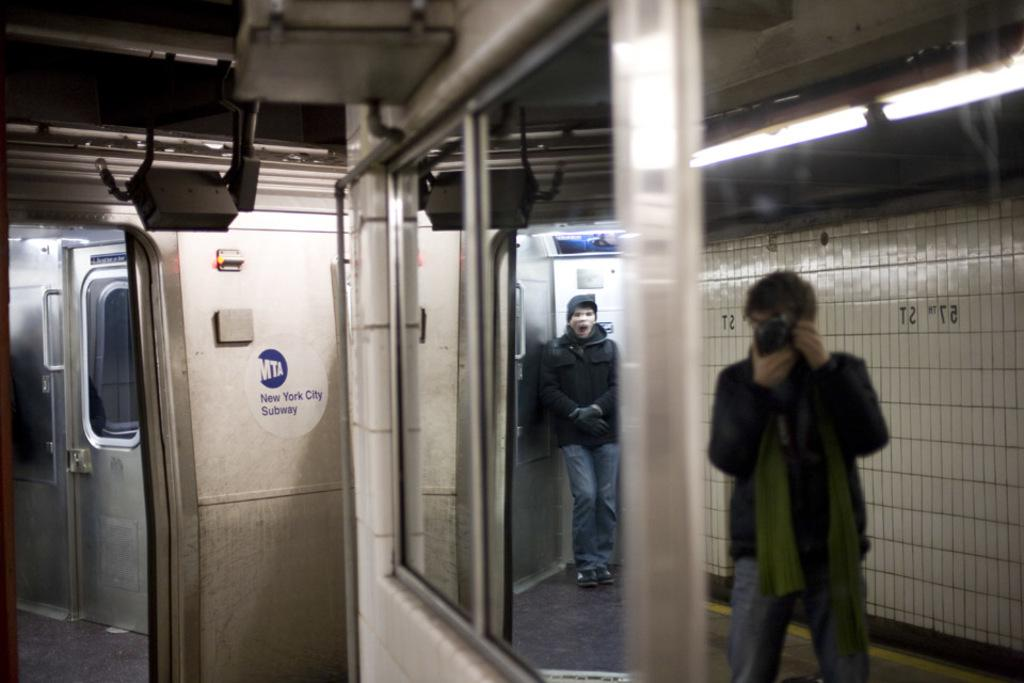<image>
Write a terse but informative summary of the picture. a person taking a photo on the New York City subway 